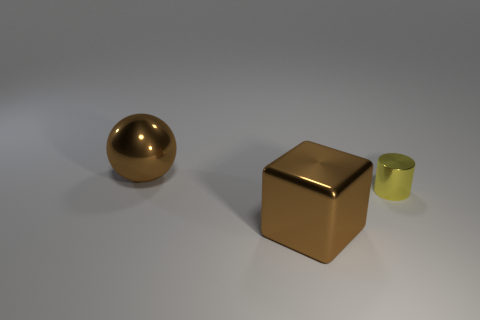Add 2 big metallic spheres. How many objects exist? 5 Subtract all blocks. How many objects are left? 2 Add 2 yellow cylinders. How many yellow cylinders exist? 3 Subtract 0 purple blocks. How many objects are left? 3 Subtract all large brown spheres. Subtract all purple rubber cylinders. How many objects are left? 2 Add 2 shiny cubes. How many shiny cubes are left? 3 